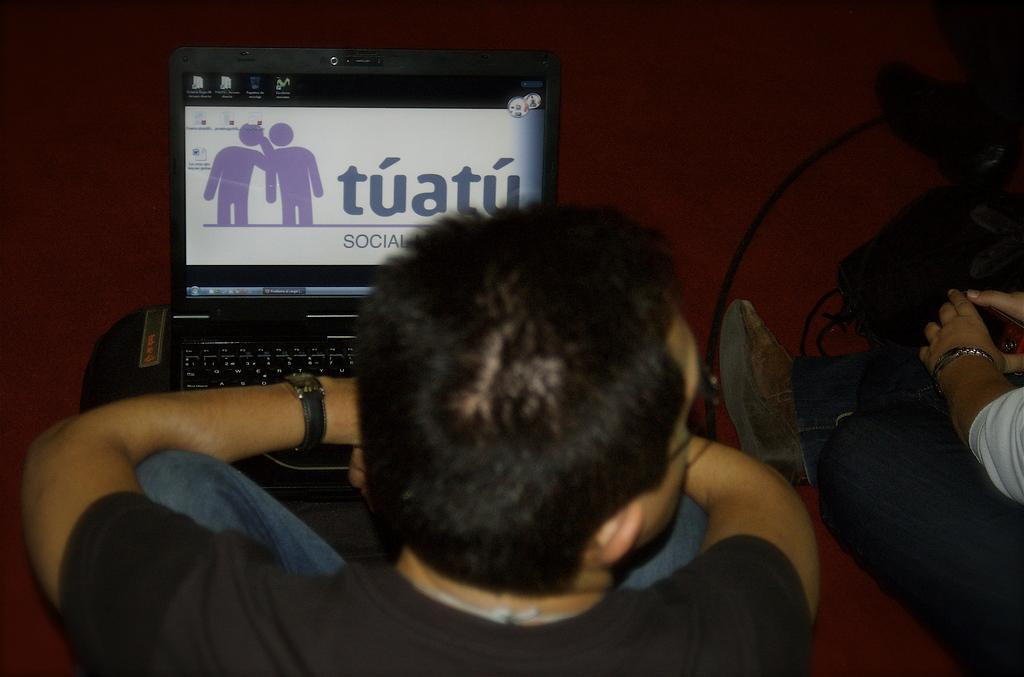<image>
Render a clear and concise summary of the photo. A man sits in front of a laptop with Tuatu on its screen. 